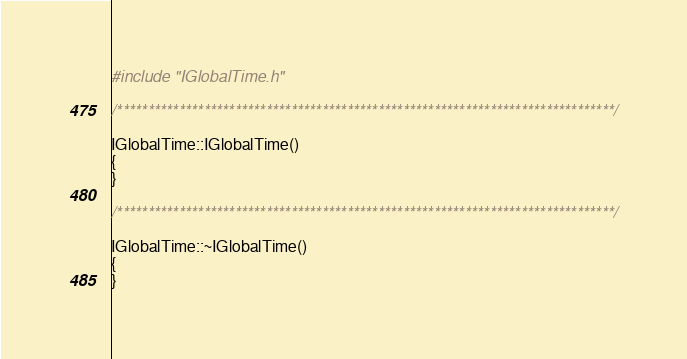<code> <loc_0><loc_0><loc_500><loc_500><_C++_>
#include "IGlobalTime.h"

/********************************************************************************/

IGlobalTime::IGlobalTime()
{
}

/********************************************************************************/

IGlobalTime::~IGlobalTime()
{
}

</code> 